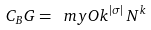Convert formula to latex. <formula><loc_0><loc_0><loc_500><loc_500>C _ { B } G = \ m y O { k ^ { | \sigma | } \, N ^ { k } }</formula> 